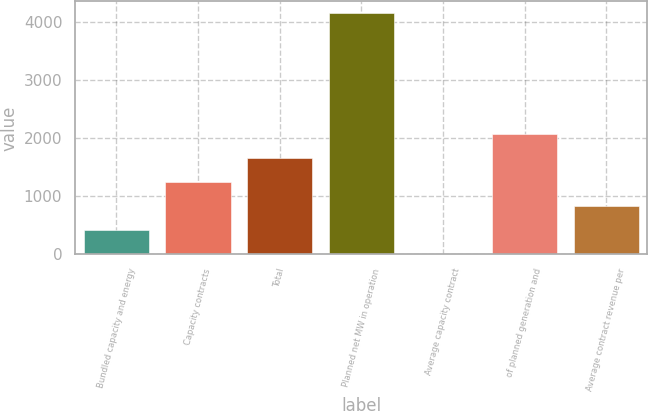<chart> <loc_0><loc_0><loc_500><loc_500><bar_chart><fcel>Bundled capacity and energy<fcel>Capacity contracts<fcel>Total<fcel>Planned net MW in operation<fcel>Average capacity contract<fcel>of planned generation and<fcel>Average contract revenue per<nl><fcel>416.58<fcel>1247.34<fcel>1662.72<fcel>4155<fcel>1.2<fcel>2078.1<fcel>831.96<nl></chart> 